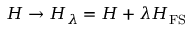Convert formula to latex. <formula><loc_0><loc_0><loc_500><loc_500>H \rightarrow H _ { \lambda } = H + \lambda H _ { F S }</formula> 